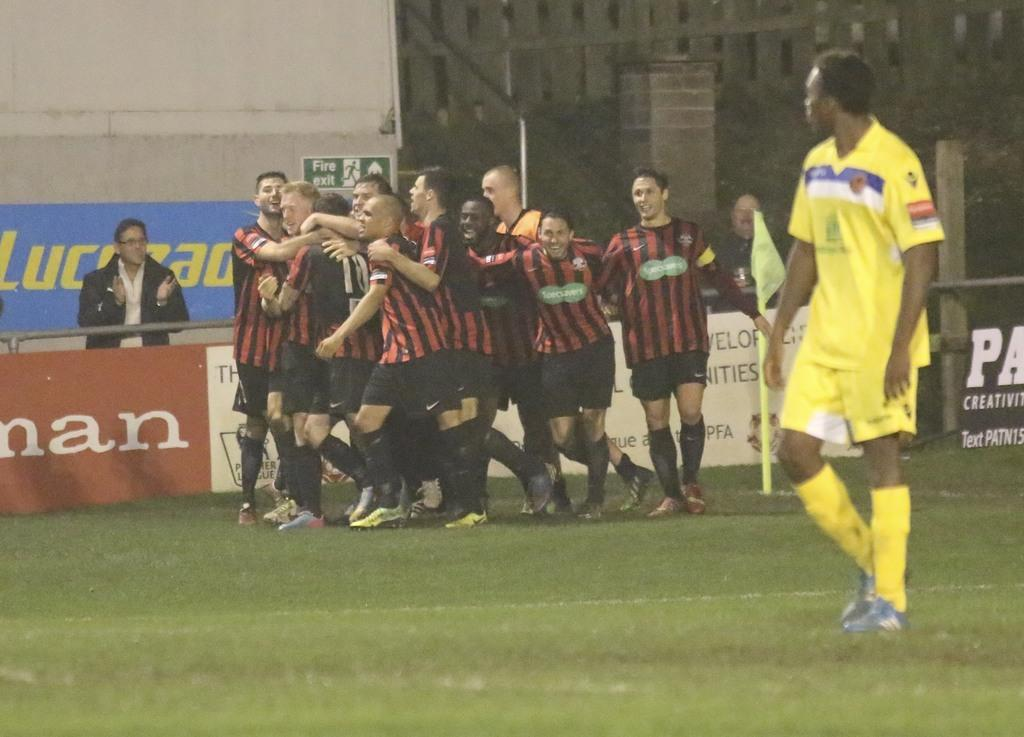<image>
Share a concise interpretation of the image provided. Soccer players in red and black striped jerseys celebrate near a sign for a fire exit. 